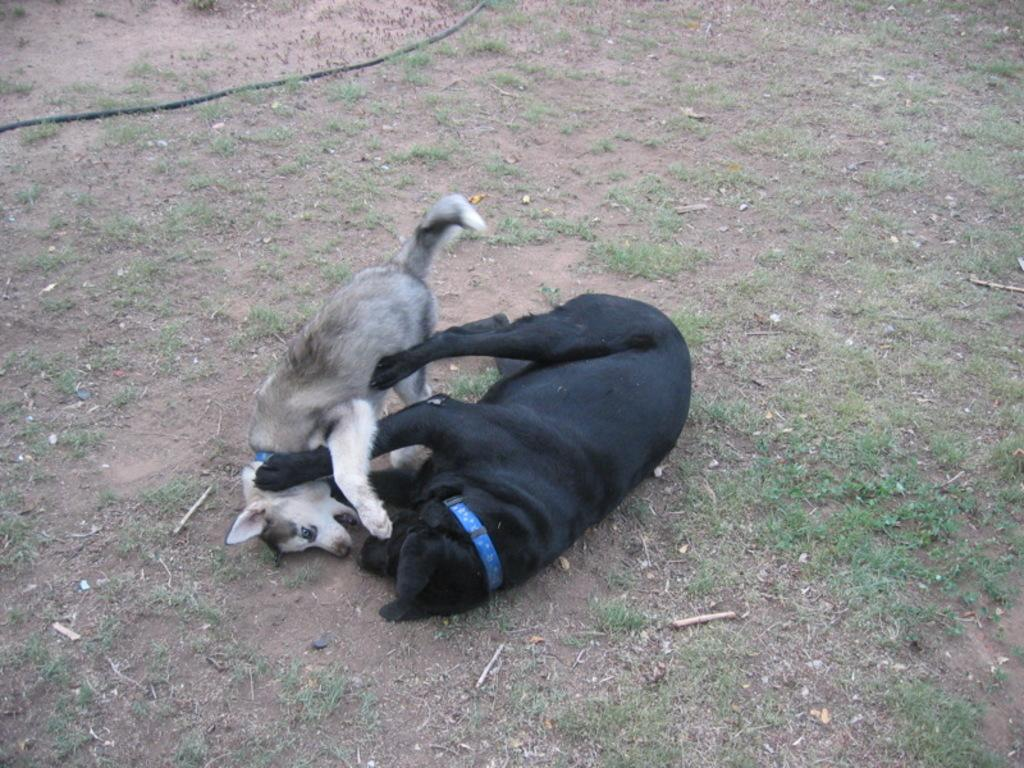How many dogs are present in the image? There are two dogs in the image. What are the dogs doing in the image? The dogs are fighting in the image. What type of terrain can be seen in the image? There is grass and sand visible in the image. What type of smile can be seen on the earth in the image? There is no earth or smile present in the image; it features two dogs fighting on a grass and sand terrain. 